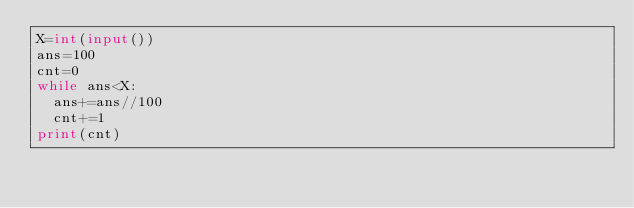<code> <loc_0><loc_0><loc_500><loc_500><_Python_>X=int(input())
ans=100
cnt=0
while ans<X:
  ans+=ans//100
  cnt+=1
print(cnt)</code> 